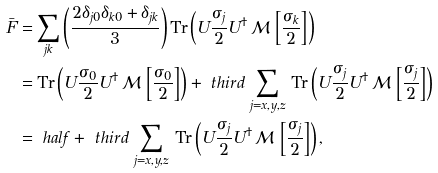Convert formula to latex. <formula><loc_0><loc_0><loc_500><loc_500>\bar { F } & = \sum _ { j k } \left ( \frac { 2 \delta _ { j 0 } \delta _ { k 0 } + \delta _ { j k } } { 3 } \right ) \text {Tr} \left ( U \frac { \sigma _ { j } } { 2 } U ^ { \dagger } \, \mathcal { M } \, \left [ \frac { \sigma _ { k } } { 2 } \right ] \right ) \\ & = \text {Tr} \left ( U \frac { \sigma _ { 0 } } { 2 } U ^ { \dagger } \, \mathcal { M } \, \left [ \frac { \sigma _ { 0 } } { 2 } \right ] \right ) + \ t h i r d \, \sum _ { j = x , y , z } \, \text {Tr} \left ( U \frac { \sigma _ { j } } { 2 } U ^ { \dagger } \, \mathcal { M } \, \left [ \frac { \sigma _ { j } } { 2 } \right ] \right ) \\ & = \ h a l f + \ t h i r d \, \sum _ { j = x , y , z } \, \text {Tr} \left ( U \frac { \sigma _ { j } } { 2 } U ^ { \dagger } \, \mathcal { M } \, \left [ \frac { \sigma _ { j } } { 2 } \right ] \right ) ,</formula> 